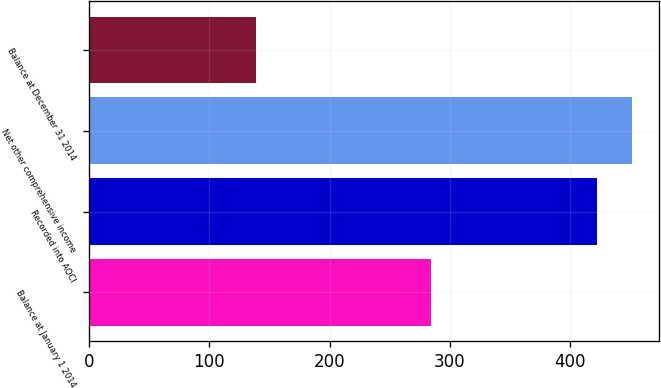Convert chart. <chart><loc_0><loc_0><loc_500><loc_500><bar_chart><fcel>Balance at January 1 2014<fcel>Recorded into AOCI<fcel>Net other comprehensive income<fcel>Balance at December 31 2014<nl><fcel>284.3<fcel>422.8<fcel>451.23<fcel>138.5<nl></chart> 